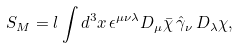<formula> <loc_0><loc_0><loc_500><loc_500>S _ { M } = l \int d ^ { 3 } x \, \epsilon ^ { \mu \nu \lambda } D _ { \mu } \bar { \chi } \, \hat { \gamma } _ { \nu } \, D _ { \lambda } \chi ,</formula> 